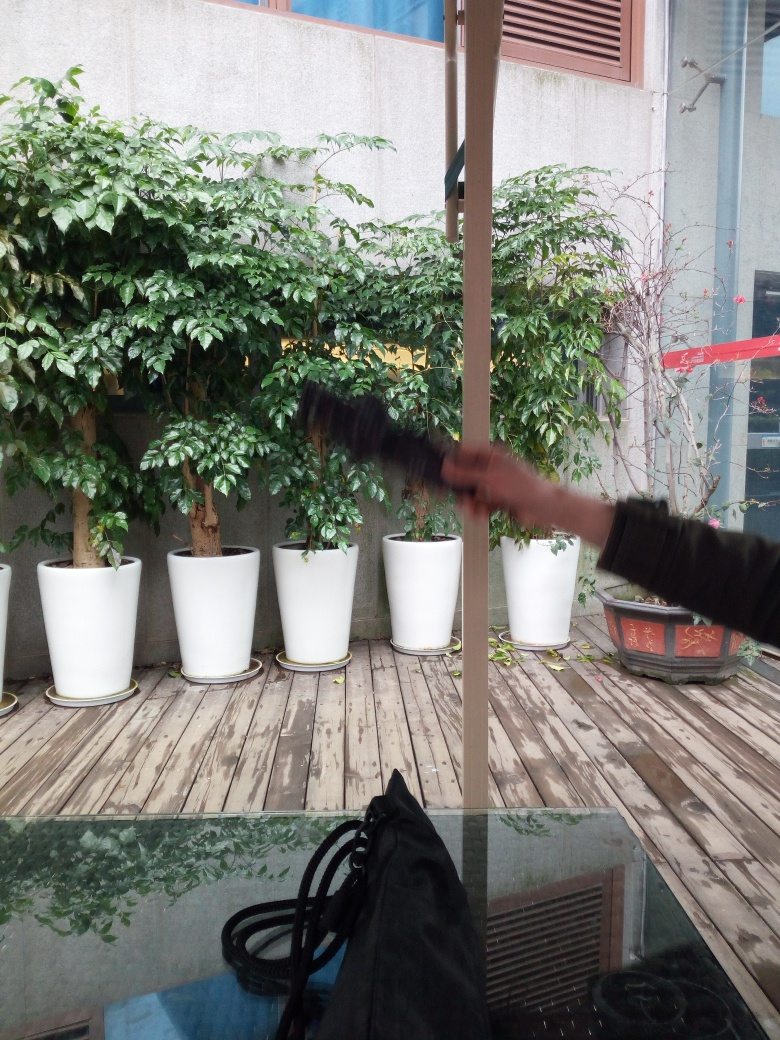What's the weather like outside? The overcast sky suggests that it might be a cloudy day, with the potential for rain. The leaves on the trees do not appear to be moving much which might indicate that there's not much wind. 